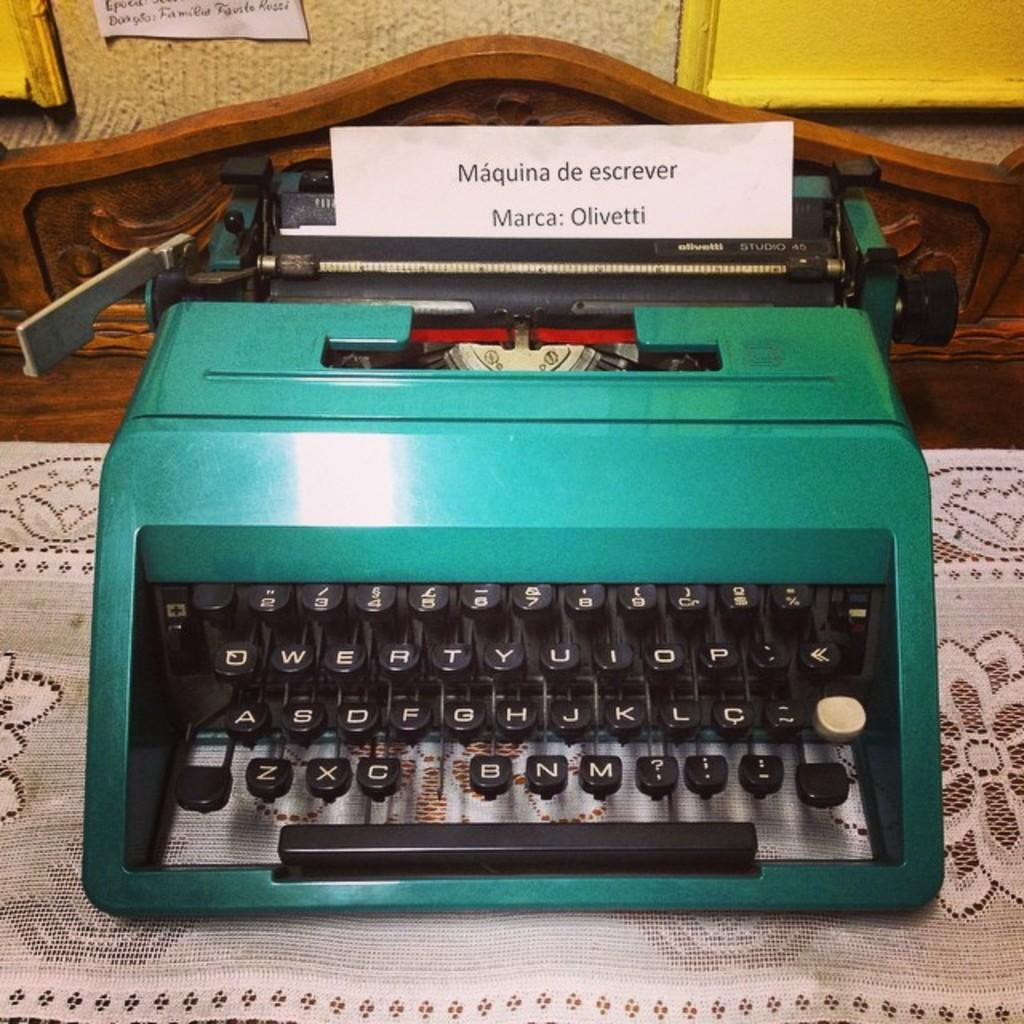Provide a one-sentence caption for the provided image. An old teal colored typewriter that has a typed sheet of paper with Maquina de escrever marca: Olivetti typed on it. 